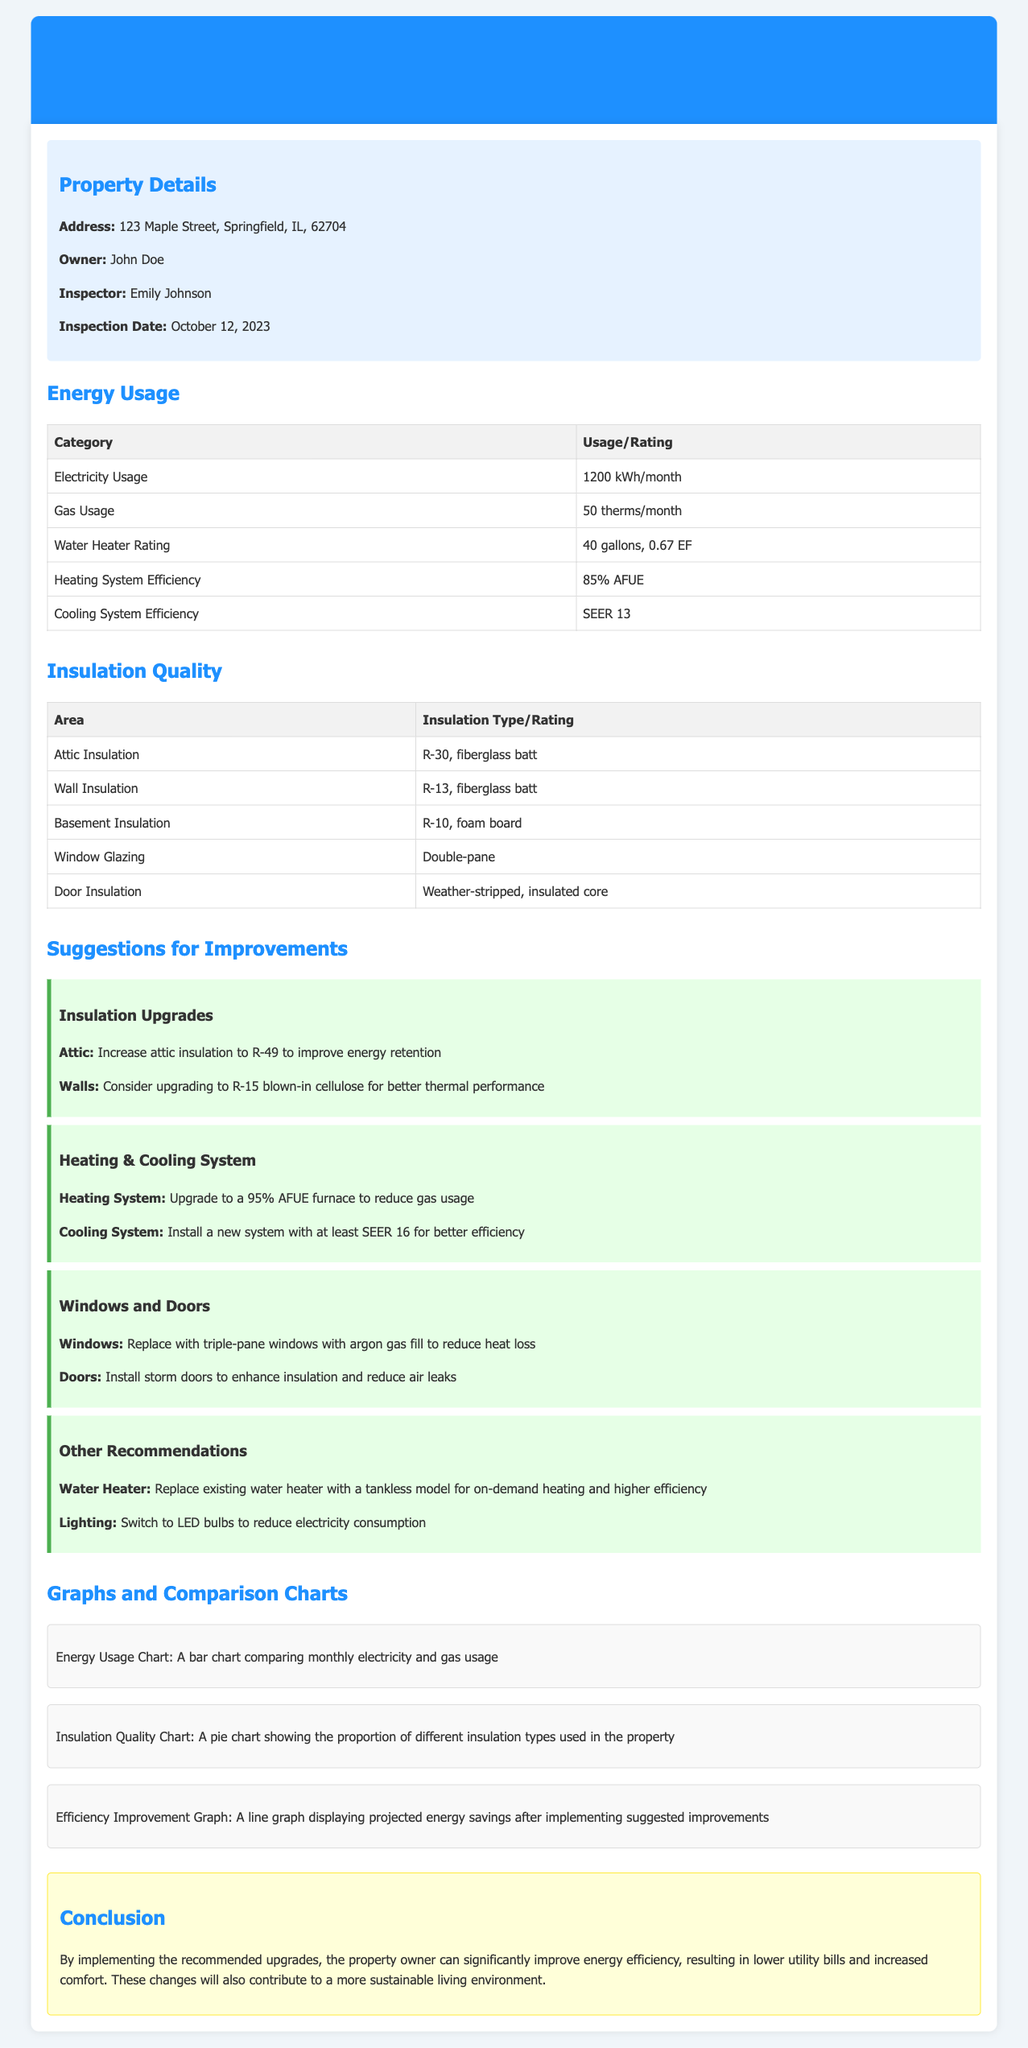What is the address of the property? The address of the property is listed in the property details section of the document.
Answer: 123 Maple Street, Springfield, IL, 62704 Who is the inspector? The inspector's name is provided in the property details section of the document.
Answer: Emily Johnson What is the electricity usage per month? The electricity usage is stated in the energy usage section of the document.
Answer: 1200 kWh/month What insulation type is used in the attic? The insulation type in the attic is specified in the insulation quality section.
Answer: R-30, fiberglass batt What is the suggested AFUE for the new heating system? The recommended AFUE for the heating system is mentioned in the suggestions for improvements section.
Answer: 95% AFUE How many gallons is the water heater? The water heater capacity is included in the energy usage section of the document.
Answer: 40 gallons What type of windows are suggested for replacement? The recommendation for windows is stated in the suggestions for improvements section.
Answer: Triple-pane windows with argon gas fill What is the cooling system efficiency rating? The efficiency rating of the cooling system is provided in the energy usage section.
Answer: SEER 13 What is the conclusion about the energy efficiency upgrades? The conclusion summarizes the overall findings and benefits of the suggested upgrades.
Answer: Improve energy efficiency, resulting in lower utility bills and increased comfort 